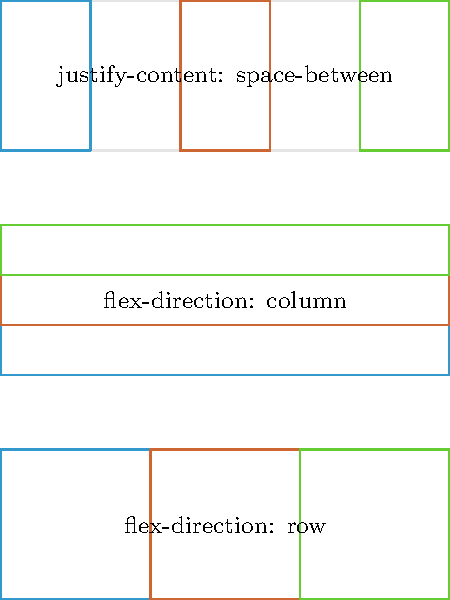Match the following CSS flexbox container properties to their corresponding visual outcomes (A, B, C) shown in the diagram:

1. flex-direction: row
2. flex-direction: column
3. justify-content: space-between Let's analyze each flexbox container property and its visual representation:

1. flex-direction: row
   - This property aligns flex items horizontally in a row.
   - In the diagram, this corresponds to option A, where the colored boxes are arranged side by side from left to right.

2. flex-direction: column
   - This property stacks flex items vertically in a column.
   - In the diagram, this corresponds to option B, where the colored boxes are stacked on top of each other from top to bottom.

3. justify-content: space-between
   - This property distributes flex items evenly along the main axis, with the first item at the start and the last item at the end.
   - In the diagram, this corresponds to option C, where the colored boxes are spread out with equal space between them, touching the edges of the container.

By carefully observing the layout of the colored boxes in each option and matching them to the properties' descriptions, we can determine the correct pairing.
Answer: 1-A, 2-B, 3-C 